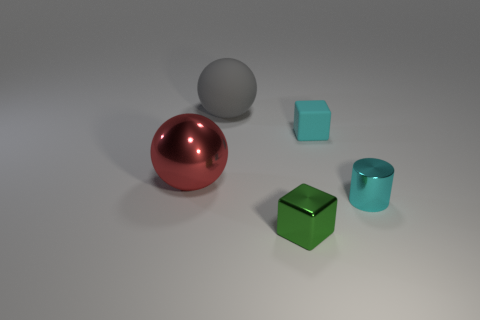What number of things are either tiny cyan things to the left of the tiny metallic cylinder or big red cubes?
Your answer should be compact. 1. There is a block in front of the tiny rubber thing; is its color the same as the tiny rubber cube?
Your answer should be very brief. No. How many other objects are there of the same color as the big matte object?
Make the answer very short. 0. How many small things are either red metal cylinders or cyan matte things?
Offer a very short reply. 1. Is the number of tiny cyan things greater than the number of red rubber cylinders?
Ensure brevity in your answer.  Yes. Is the material of the red thing the same as the small cylinder?
Give a very brief answer. Yes. Are there any other things that are made of the same material as the big red object?
Ensure brevity in your answer.  Yes. Is the number of tiny cyan shiny objects in front of the metallic cylinder greater than the number of large red metallic objects?
Provide a short and direct response. No. Does the tiny metal cube have the same color as the big shiny sphere?
Give a very brief answer. No. How many other matte things are the same shape as the red thing?
Keep it short and to the point. 1. 